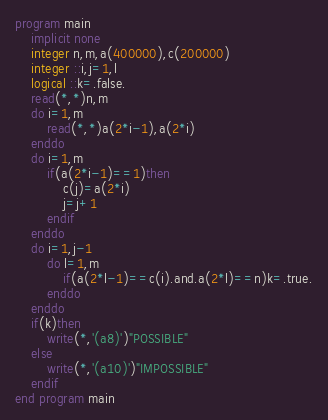<code> <loc_0><loc_0><loc_500><loc_500><_FORTRAN_>program main
	implicit none
	integer n,m,a(400000),c(200000)
	integer ::i,j=1,l
	logical ::k=.false.
	read(*,*)n,m
	do i=1,m
		read(*,*)a(2*i-1),a(2*i)
	enddo
	do i=1,m
		if(a(2*i-1)==1)then
			c(j)=a(2*i)
			j=j+1
		endif
	enddo
	do i=1,j-1
		do l=1,m
			if(a(2*l-1)==c(i).and.a(2*l)==n)k=.true.
		enddo
	enddo
	if(k)then
		write(*,'(a8)')"POSSIBLE"
	else
		write(*,'(a10)')"IMPOSSIBLE"
	endif
end program main
</code> 